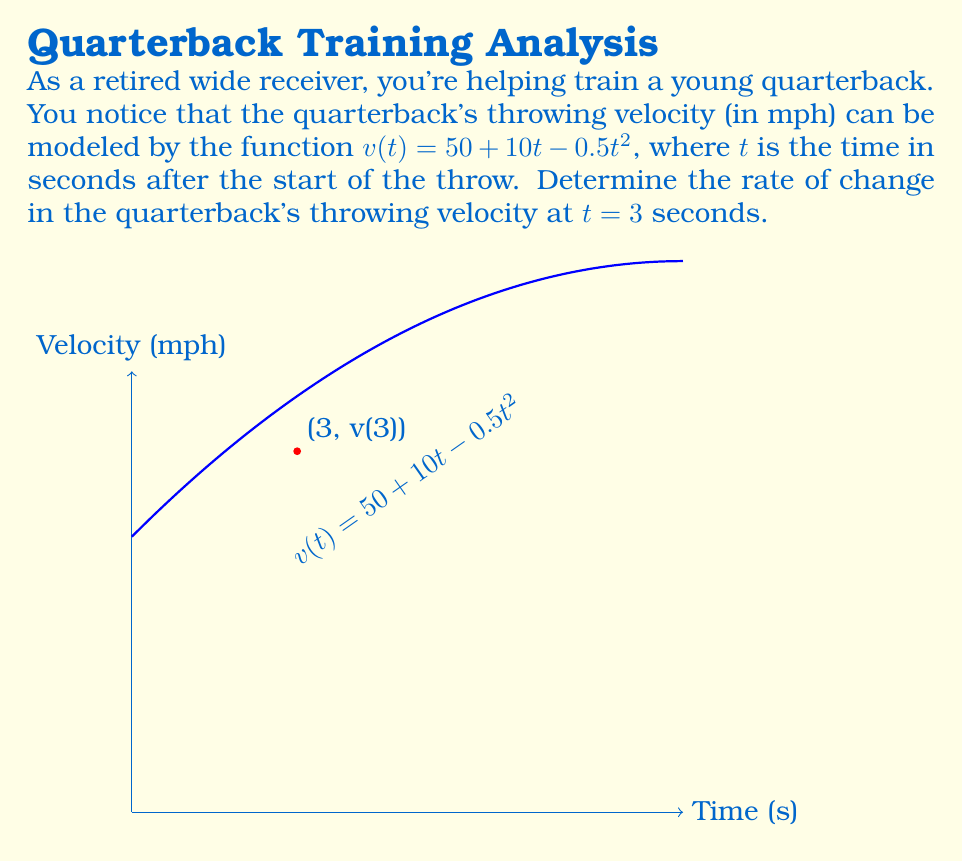Can you solve this math problem? To find the rate of change in velocity at a specific time, we need to calculate the derivative of the velocity function and evaluate it at the given time.

1) The velocity function is given as:
   $v(t) = 50 + 10t - 0.5t^2$

2) To find the derivative, we apply the power rule:
   $\frac{dv}{dt} = 0 + 10 - 0.5(2t)$
   $\frac{dv}{dt} = 10 - t$

3) This derivative function represents the instantaneous rate of change of velocity, or acceleration.

4) To find the rate of change at $t = 3$ seconds, we substitute $t = 3$ into our derivative function:
   $\frac{dv}{dt}|_{t=3} = 10 - 3 = 7$

5) Therefore, at $t = 3$ seconds, the rate of change of the quarterback's throwing velocity is 7 mph/s.

Note: The positive value indicates that the velocity is still increasing at this point, but at a slower rate than initially due to the negative quadratic term in the original function.
Answer: 7 mph/s 